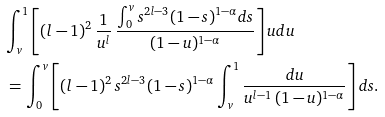Convert formula to latex. <formula><loc_0><loc_0><loc_500><loc_500>& \int _ { v } ^ { 1 } \left [ \left ( l - 1 \right ) ^ { 2 } \frac { 1 } { u ^ { l } } \, \frac { \int _ { 0 } ^ { v } s ^ { 2 l - 3 } ( 1 - s ) ^ { 1 - \alpha } d s } { ( 1 - u ) ^ { 1 - \alpha } } \right ] u d u \\ & \, = \int _ { 0 } ^ { v } \left [ \left ( l - 1 \right ) ^ { 2 } s ^ { 2 l - 3 } ( 1 - s ) ^ { 1 - \alpha } \int _ { v } ^ { 1 } \frac { d u } { u ^ { l - 1 } \, ( 1 - u ) ^ { 1 - \alpha } } \right ] d s .</formula> 